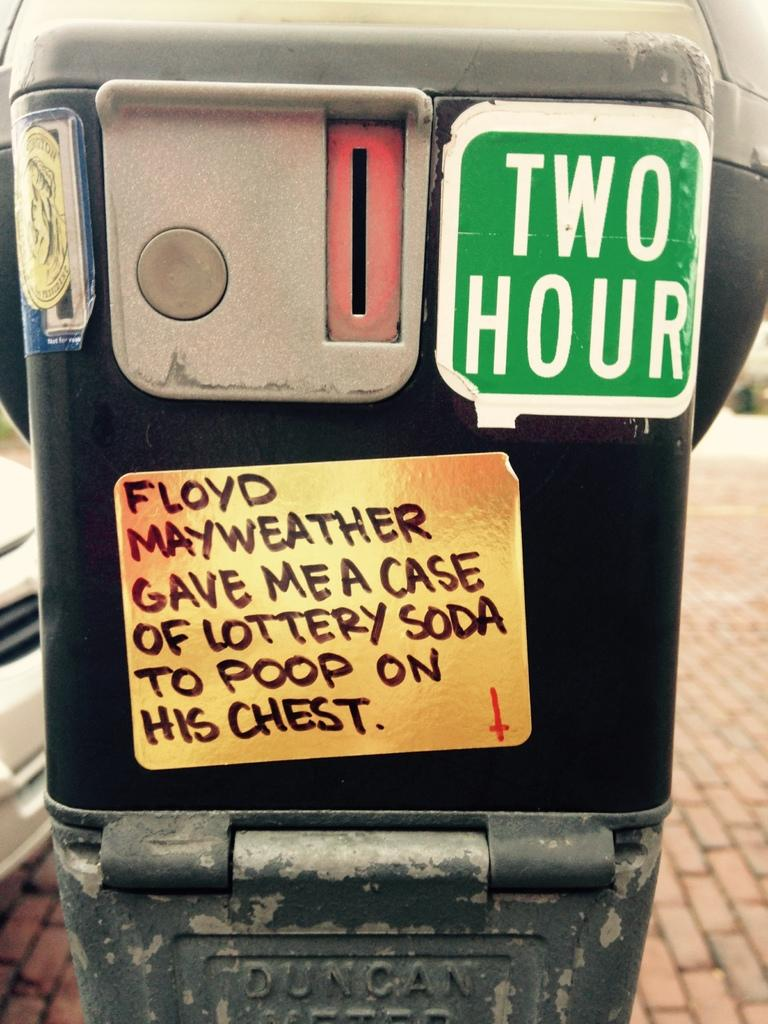What is located in the foreground of the image? There is a box in the foreground of the image. What can be seen on the box? There is text on the box. What type of objects can be seen in the background of the image? There are vehicles in the background of the image. What is at the bottom of the image? There is a walkway at the bottom of the image. What type of line can be seen connecting the insects in the image? There are no insects present in the image, so there is no line connecting them. 